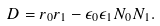<formula> <loc_0><loc_0><loc_500><loc_500>D = r _ { 0 } r _ { 1 } - \epsilon _ { 0 } \epsilon _ { 1 } N _ { 0 } N _ { 1 } .</formula> 